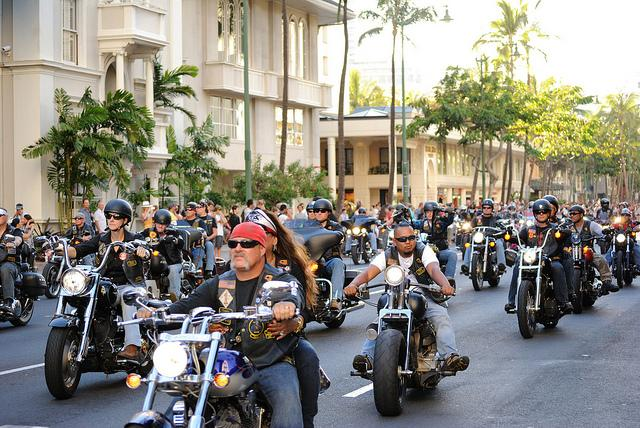What is the main reason hundreds of bikers would be riding together down a main street? rally 